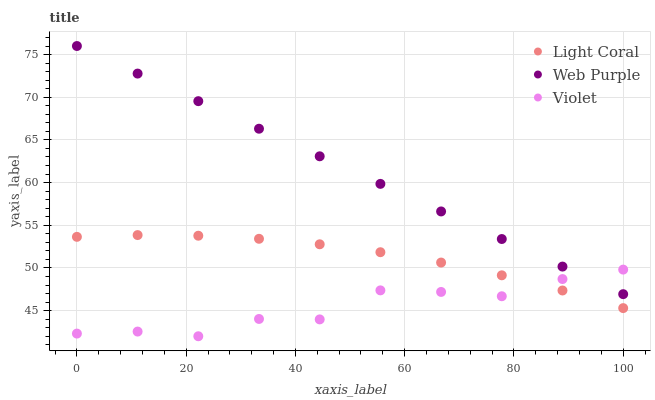Does Violet have the minimum area under the curve?
Answer yes or no. Yes. Does Web Purple have the maximum area under the curve?
Answer yes or no. Yes. Does Web Purple have the minimum area under the curve?
Answer yes or no. No. Does Violet have the maximum area under the curve?
Answer yes or no. No. Is Web Purple the smoothest?
Answer yes or no. Yes. Is Violet the roughest?
Answer yes or no. Yes. Is Violet the smoothest?
Answer yes or no. No. Is Web Purple the roughest?
Answer yes or no. No. Does Violet have the lowest value?
Answer yes or no. Yes. Does Web Purple have the lowest value?
Answer yes or no. No. Does Web Purple have the highest value?
Answer yes or no. Yes. Does Violet have the highest value?
Answer yes or no. No. Is Light Coral less than Web Purple?
Answer yes or no. Yes. Is Web Purple greater than Light Coral?
Answer yes or no. Yes. Does Web Purple intersect Violet?
Answer yes or no. Yes. Is Web Purple less than Violet?
Answer yes or no. No. Is Web Purple greater than Violet?
Answer yes or no. No. Does Light Coral intersect Web Purple?
Answer yes or no. No. 